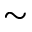<formula> <loc_0><loc_0><loc_500><loc_500>\sim</formula> 